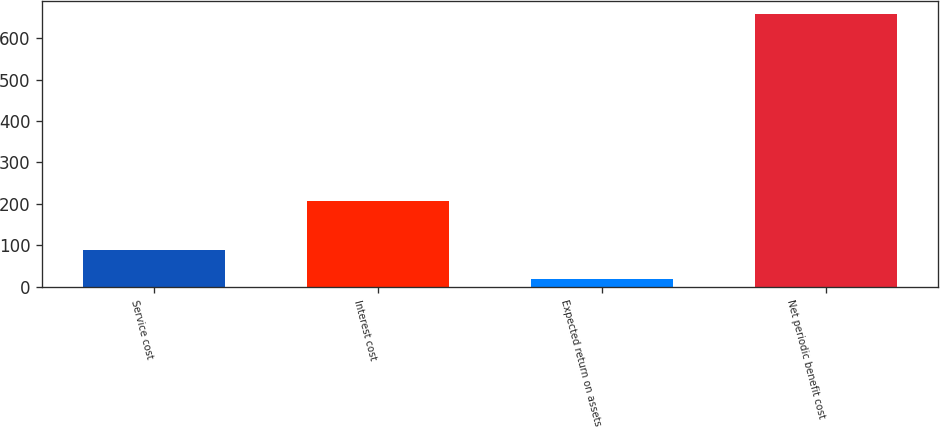<chart> <loc_0><loc_0><loc_500><loc_500><bar_chart><fcel>Service cost<fcel>Interest cost<fcel>Expected return on assets<fcel>Net periodic benefit cost<nl><fcel>89<fcel>208<fcel>18<fcel>658<nl></chart> 